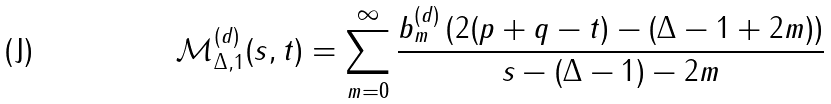<formula> <loc_0><loc_0><loc_500><loc_500>\mathcal { M } ^ { ( d ) } _ { \Delta , 1 } ( s , t ) = \sum _ { m = 0 } ^ { \infty } \frac { b ^ { ( d ) } _ { m } \left ( 2 ( p + q - t ) - ( \Delta - 1 + 2 m ) \right ) } { s - ( \Delta - 1 ) - 2 m }</formula> 